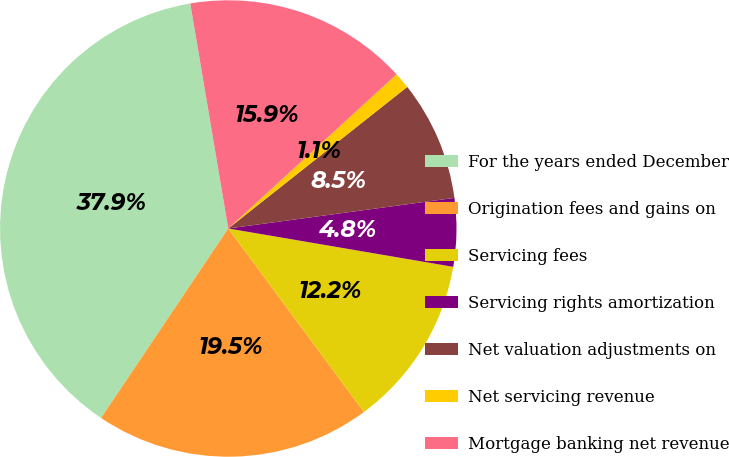<chart> <loc_0><loc_0><loc_500><loc_500><pie_chart><fcel>For the years ended December<fcel>Origination fees and gains on<fcel>Servicing fees<fcel>Servicing rights amortization<fcel>Net valuation adjustments on<fcel>Net servicing revenue<fcel>Mortgage banking net revenue<nl><fcel>37.93%<fcel>19.54%<fcel>12.18%<fcel>4.83%<fcel>8.51%<fcel>1.15%<fcel>15.86%<nl></chart> 